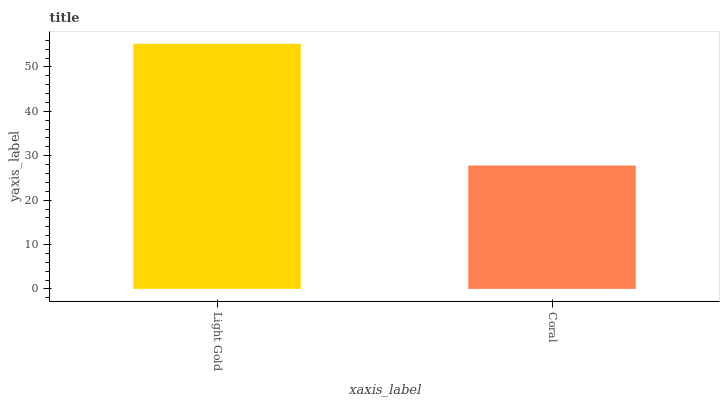Is Coral the minimum?
Answer yes or no. Yes. Is Light Gold the maximum?
Answer yes or no. Yes. Is Coral the maximum?
Answer yes or no. No. Is Light Gold greater than Coral?
Answer yes or no. Yes. Is Coral less than Light Gold?
Answer yes or no. Yes. Is Coral greater than Light Gold?
Answer yes or no. No. Is Light Gold less than Coral?
Answer yes or no. No. Is Light Gold the high median?
Answer yes or no. Yes. Is Coral the low median?
Answer yes or no. Yes. Is Coral the high median?
Answer yes or no. No. Is Light Gold the low median?
Answer yes or no. No. 